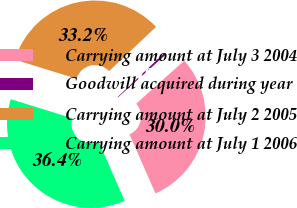Convert chart. <chart><loc_0><loc_0><loc_500><loc_500><pie_chart><fcel>Carrying amount at July 3 2004<fcel>Goodwill acquired during year<fcel>Carrying amount at July 2 2005<fcel>Carrying amount at July 1 2006<nl><fcel>30.03%<fcel>0.41%<fcel>33.2%<fcel>36.37%<nl></chart> 